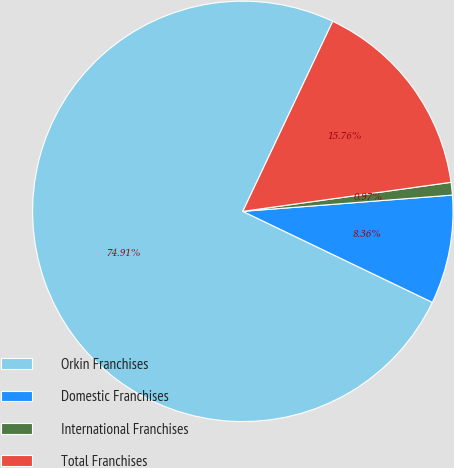<chart> <loc_0><loc_0><loc_500><loc_500><pie_chart><fcel>Orkin Franchises<fcel>Domestic Franchises<fcel>International Franchises<fcel>Total Franchises<nl><fcel>74.91%<fcel>8.36%<fcel>0.97%<fcel>15.76%<nl></chart> 